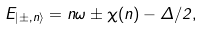Convert formula to latex. <formula><loc_0><loc_0><loc_500><loc_500>E _ { | \pm , n \rangle } = n \omega \pm \chi ( n ) - \Delta / 2 ,</formula> 